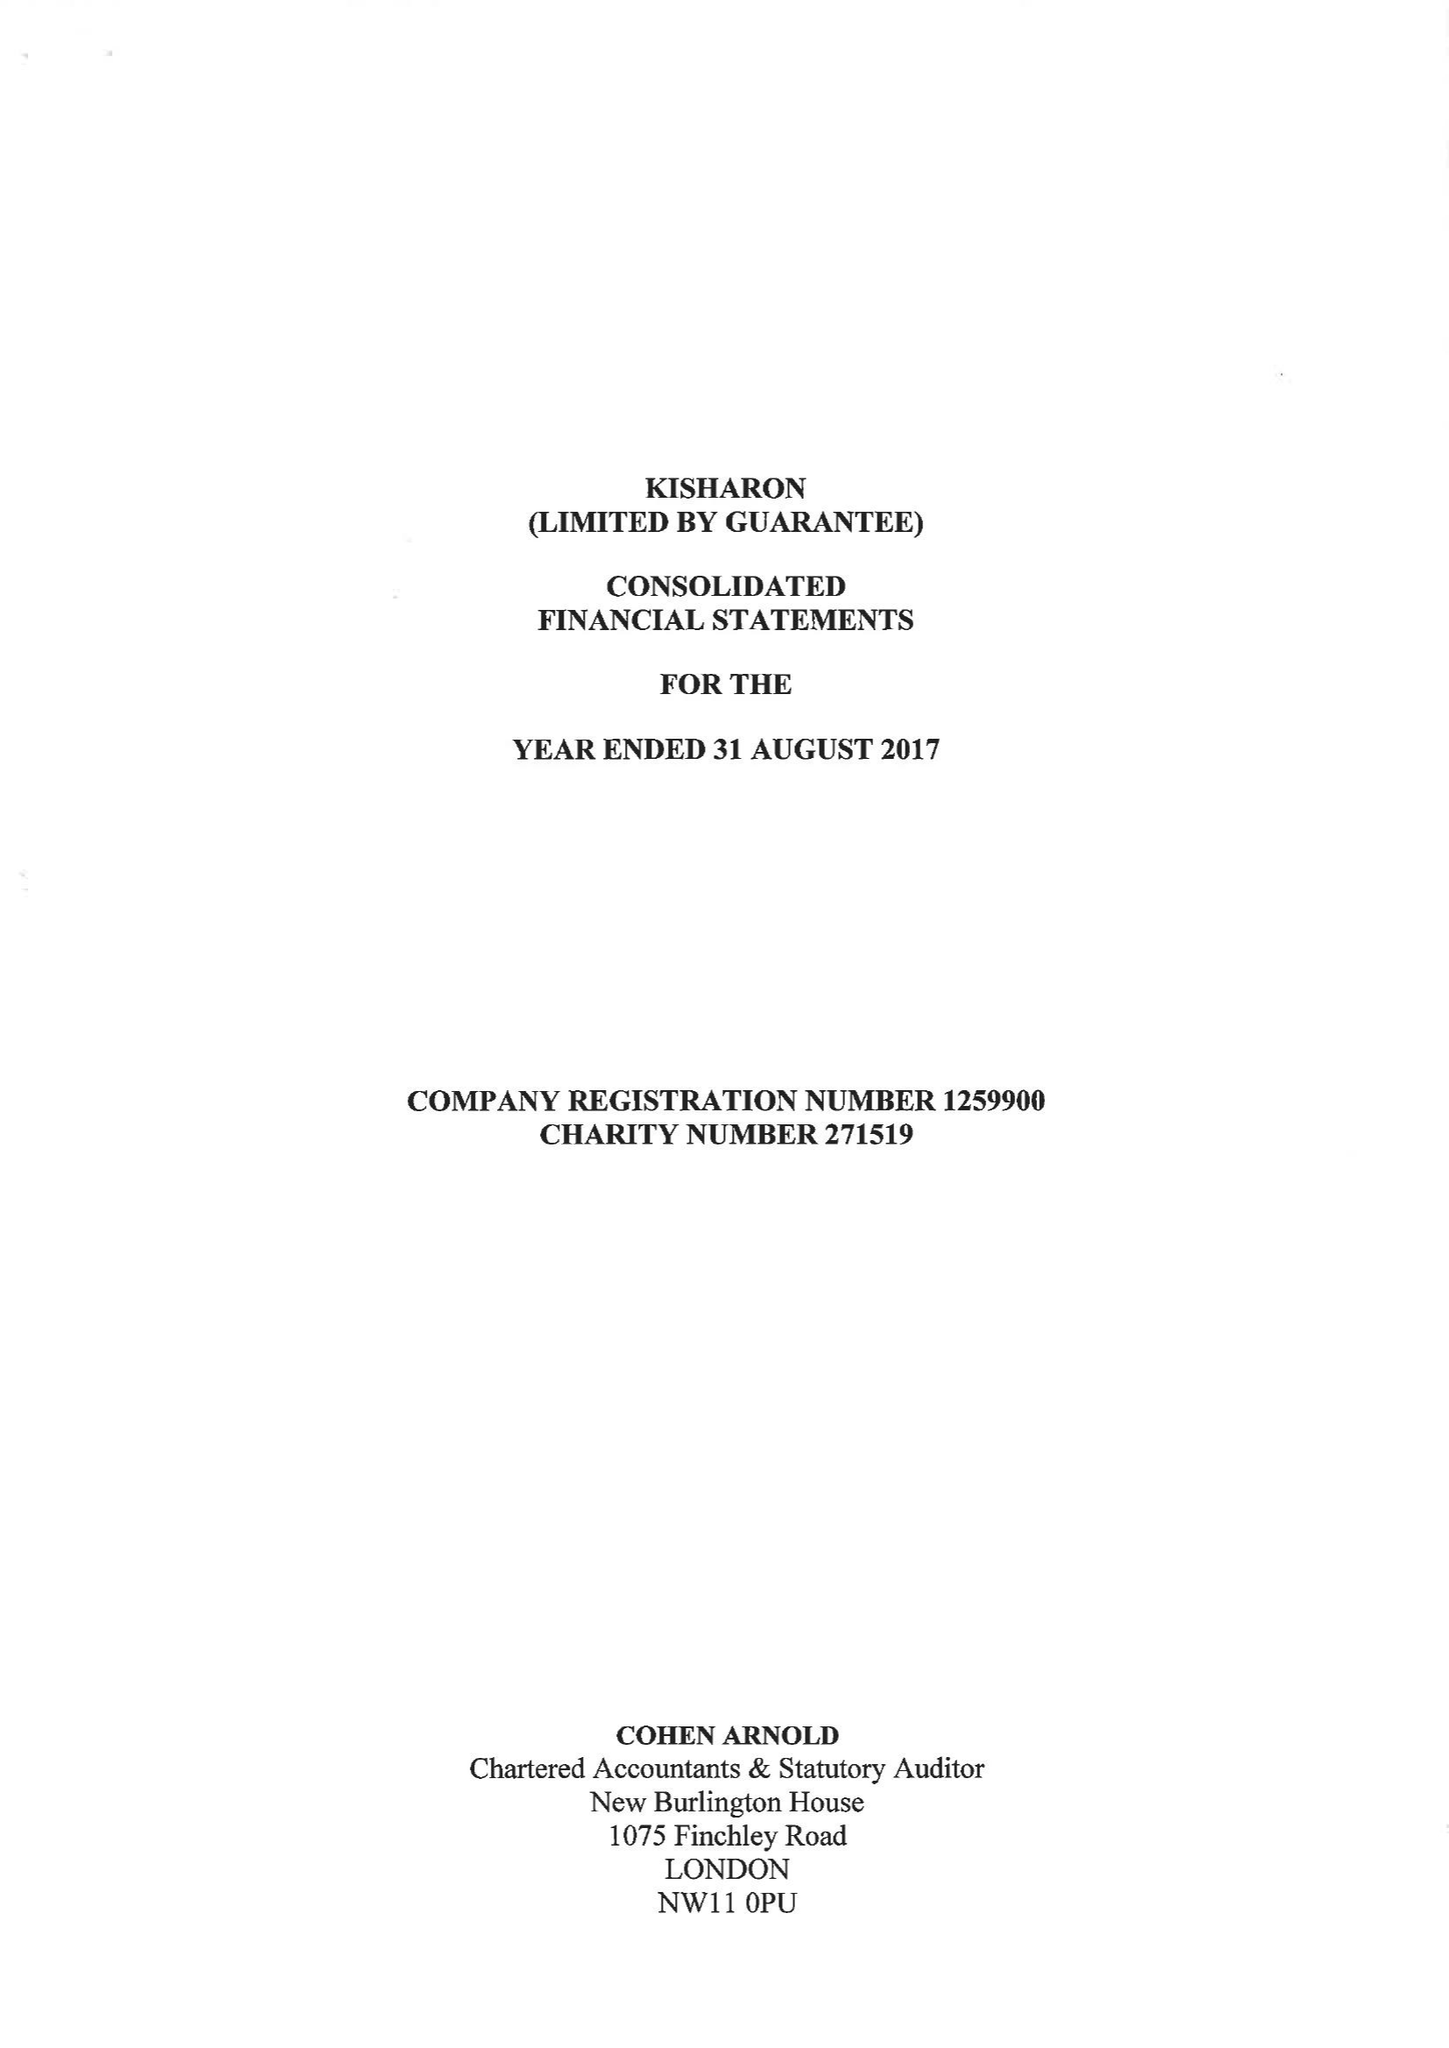What is the value for the report_date?
Answer the question using a single word or phrase. 2017-08-31 